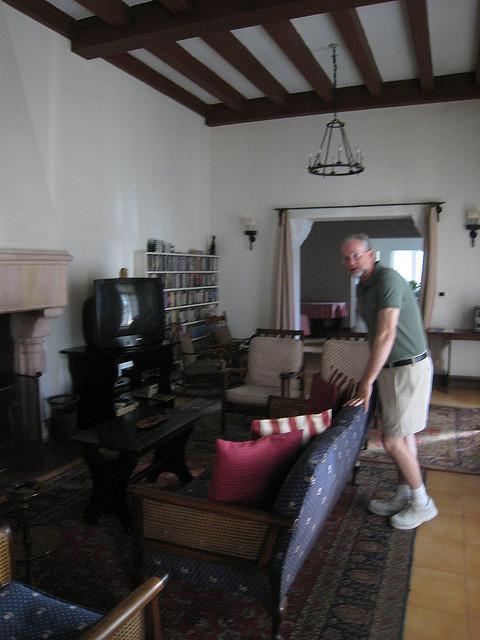How many chairs are there?
Give a very brief answer. 3. How many horses are pulling the cart?
Give a very brief answer. 0. 